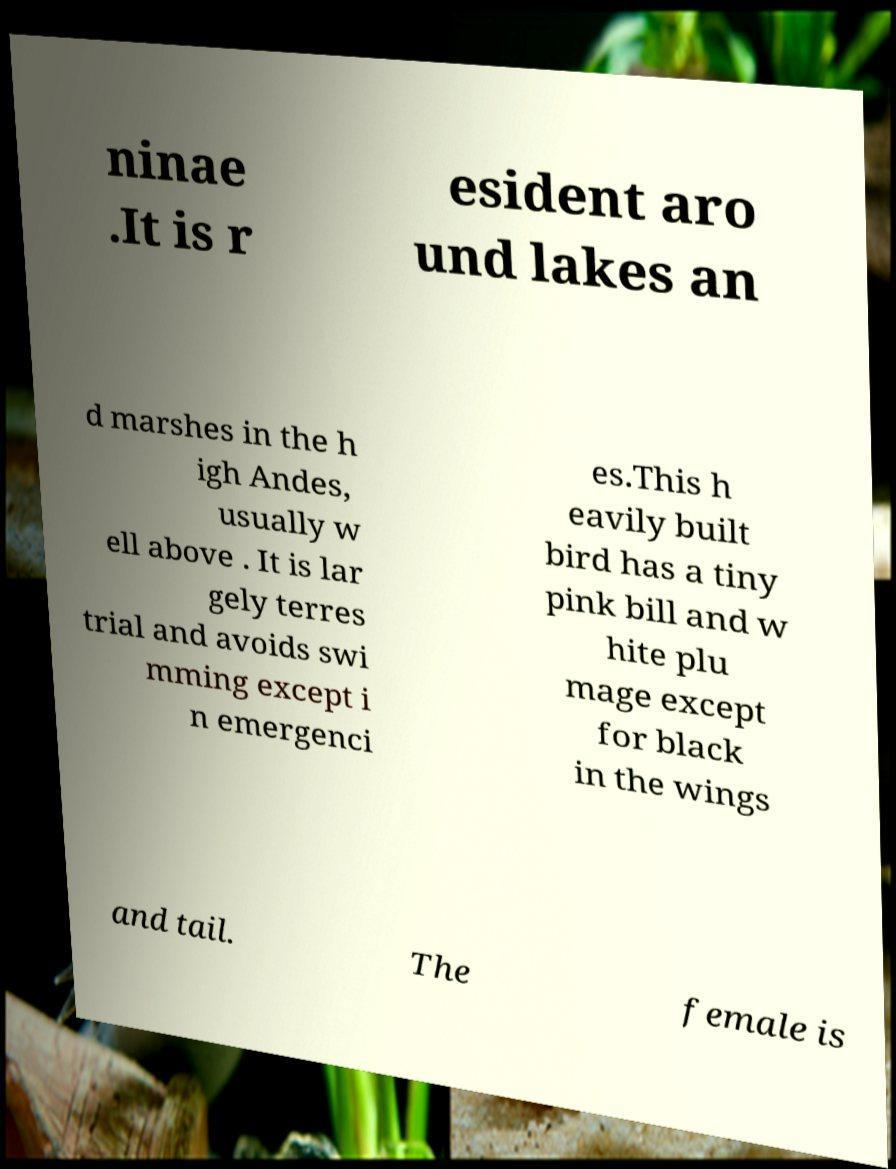Could you extract and type out the text from this image? ninae .It is r esident aro und lakes an d marshes in the h igh Andes, usually w ell above . It is lar gely terres trial and avoids swi mming except i n emergenci es.This h eavily built bird has a tiny pink bill and w hite plu mage except for black in the wings and tail. The female is 